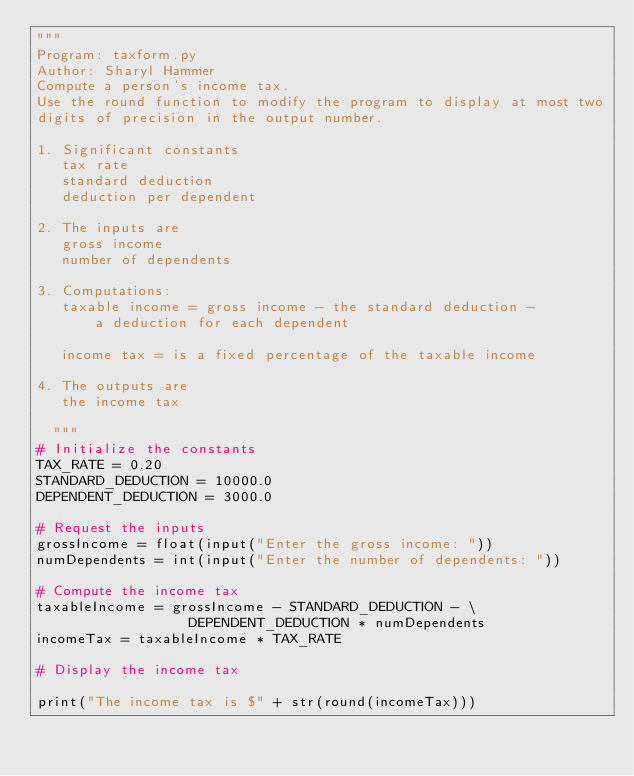<code> <loc_0><loc_0><loc_500><loc_500><_Python_>"""
Program: taxform.py
Author: Sharyl Hammer
Compute a person's income tax.
Use the round function to modify the program to display at most two
digits of precision in the output number.

1. Significant constants
   tax rate
   standard deduction
   deduction per dependent

2. The inputs are
   gross income
   number of dependents

3. Computations:
   taxable income = gross income - the standard deduction -
       a deduction for each dependent

   income tax = is a fixed percentage of the taxable income

4. The outputs are
   the income tax

  """
# Initialize the constants
TAX_RATE = 0.20
STANDARD_DEDUCTION = 10000.0
DEPENDENT_DEDUCTION = 3000.0

# Request the inputs
grossIncome = float(input("Enter the gross income: "))
numDependents = int(input("Enter the number of dependents: "))

# Compute the income tax
taxableIncome = grossIncome - STANDARD_DEDUCTION - \
                  DEPENDENT_DEDUCTION * numDependents
incomeTax = taxableIncome * TAX_RATE

# Display the income tax

print("The income tax is $" + str(round(incomeTax)))

   
</code> 